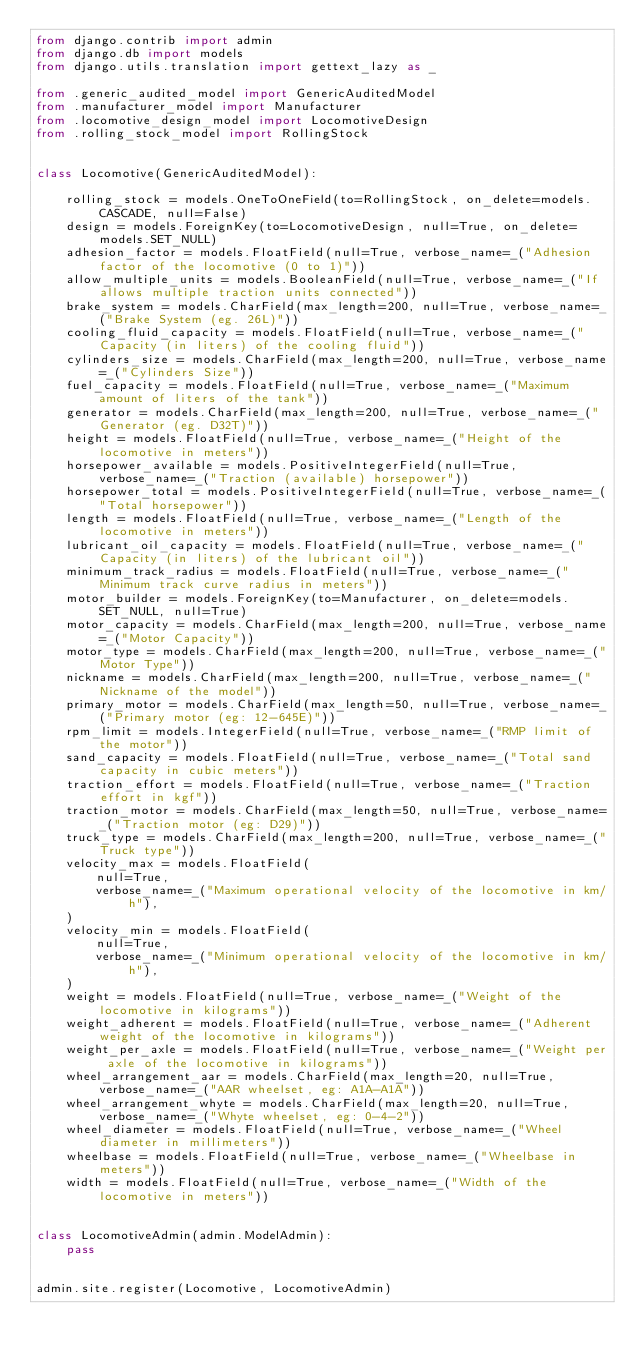Convert code to text. <code><loc_0><loc_0><loc_500><loc_500><_Python_>from django.contrib import admin
from django.db import models
from django.utils.translation import gettext_lazy as _

from .generic_audited_model import GenericAuditedModel
from .manufacturer_model import Manufacturer
from .locomotive_design_model import LocomotiveDesign
from .rolling_stock_model import RollingStock


class Locomotive(GenericAuditedModel):

    rolling_stock = models.OneToOneField(to=RollingStock, on_delete=models.CASCADE, null=False)
    design = models.ForeignKey(to=LocomotiveDesign, null=True, on_delete=models.SET_NULL)
    adhesion_factor = models.FloatField(null=True, verbose_name=_("Adhesion factor of the locomotive (0 to 1)"))
    allow_multiple_units = models.BooleanField(null=True, verbose_name=_("If allows multiple traction units connected"))
    brake_system = models.CharField(max_length=200, null=True, verbose_name=_("Brake System (eg. 26L)"))
    cooling_fluid_capacity = models.FloatField(null=True, verbose_name=_("Capacity (in liters) of the cooling fluid"))
    cylinders_size = models.CharField(max_length=200, null=True, verbose_name=_("Cylinders Size"))
    fuel_capacity = models.FloatField(null=True, verbose_name=_("Maximum amount of liters of the tank"))
    generator = models.CharField(max_length=200, null=True, verbose_name=_("Generator (eg. D32T)"))
    height = models.FloatField(null=True, verbose_name=_("Height of the locomotive in meters"))
    horsepower_available = models.PositiveIntegerField(null=True, verbose_name=_("Traction (available) horsepower"))
    horsepower_total = models.PositiveIntegerField(null=True, verbose_name=_("Total horsepower"))
    length = models.FloatField(null=True, verbose_name=_("Length of the locomotive in meters"))
    lubricant_oil_capacity = models.FloatField(null=True, verbose_name=_("Capacity (in liters) of the lubricant oil"))
    minimum_track_radius = models.FloatField(null=True, verbose_name=_("Minimum track curve radius in meters"))
    motor_builder = models.ForeignKey(to=Manufacturer, on_delete=models.SET_NULL, null=True)
    motor_capacity = models.CharField(max_length=200, null=True, verbose_name=_("Motor Capacity"))
    motor_type = models.CharField(max_length=200, null=True, verbose_name=_("Motor Type"))
    nickname = models.CharField(max_length=200, null=True, verbose_name=_("Nickname of the model"))
    primary_motor = models.CharField(max_length=50, null=True, verbose_name=_("Primary motor (eg: 12-645E)"))
    rpm_limit = models.IntegerField(null=True, verbose_name=_("RMP limit of the motor"))
    sand_capacity = models.FloatField(null=True, verbose_name=_("Total sand capacity in cubic meters"))
    traction_effort = models.FloatField(null=True, verbose_name=_("Traction effort in kgf"))
    traction_motor = models.CharField(max_length=50, null=True, verbose_name=_("Traction motor (eg: D29)"))
    truck_type = models.CharField(max_length=200, null=True, verbose_name=_("Truck type"))
    velocity_max = models.FloatField(
        null=True,
        verbose_name=_("Maximum operational velocity of the locomotive in km/h"),
    )
    velocity_min = models.FloatField(
        null=True,
        verbose_name=_("Minimum operational velocity of the locomotive in km/h"),
    )
    weight = models.FloatField(null=True, verbose_name=_("Weight of the locomotive in kilograms"))
    weight_adherent = models.FloatField(null=True, verbose_name=_("Adherent weight of the locomotive in kilograms"))
    weight_per_axle = models.FloatField(null=True, verbose_name=_("Weight per axle of the locomotive in kilograms"))
    wheel_arrangement_aar = models.CharField(max_length=20, null=True, verbose_name=_("AAR wheelset, eg: A1A-A1A"))
    wheel_arrangement_whyte = models.CharField(max_length=20, null=True, verbose_name=_("Whyte wheelset, eg: 0-4-2"))
    wheel_diameter = models.FloatField(null=True, verbose_name=_("Wheel diameter in millimeters"))
    wheelbase = models.FloatField(null=True, verbose_name=_("Wheelbase in meters"))
    width = models.FloatField(null=True, verbose_name=_("Width of the locomotive in meters"))


class LocomotiveAdmin(admin.ModelAdmin):
    pass


admin.site.register(Locomotive, LocomotiveAdmin)
</code> 